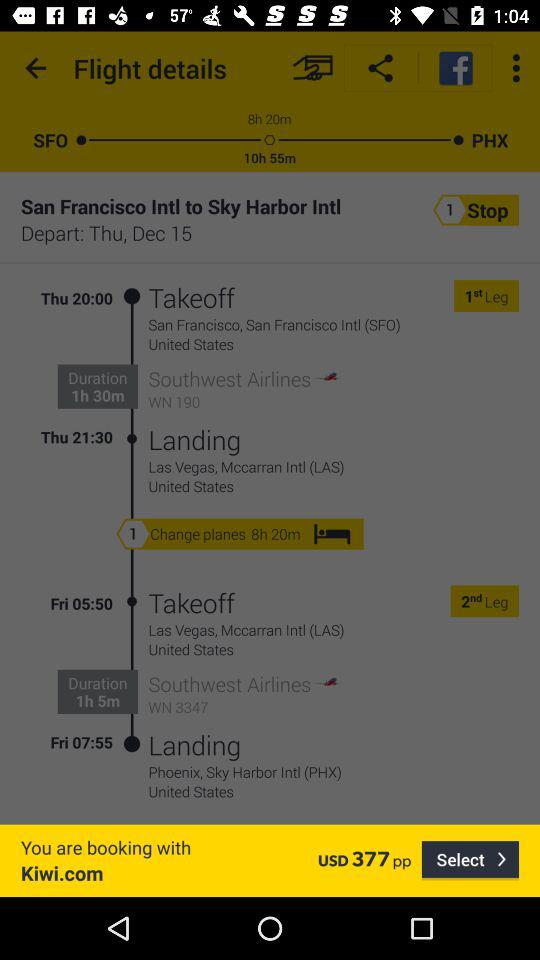What is the duration of Southwest Airlines flight WN 3347? The duration is 1 hour and 5 minutes. 